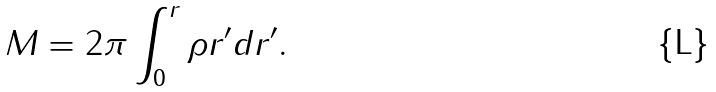Convert formula to latex. <formula><loc_0><loc_0><loc_500><loc_500>M = 2 \pi \int _ { 0 } ^ { r } \rho r ^ { \prime } d r ^ { \prime } .</formula> 